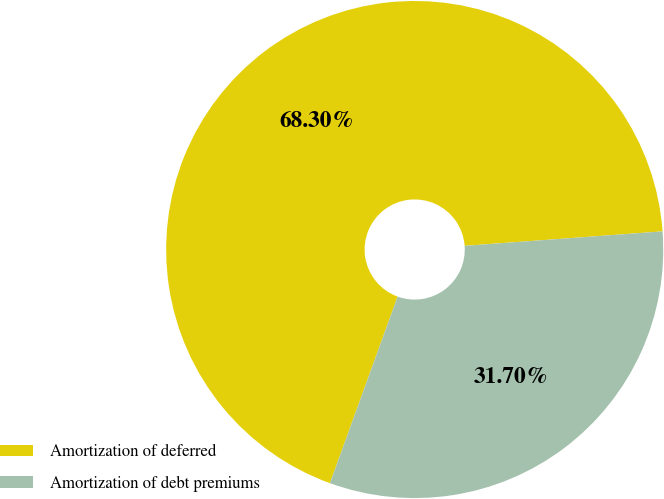Convert chart. <chart><loc_0><loc_0><loc_500><loc_500><pie_chart><fcel>Amortization of deferred<fcel>Amortization of debt premiums<nl><fcel>68.3%<fcel>31.7%<nl></chart> 